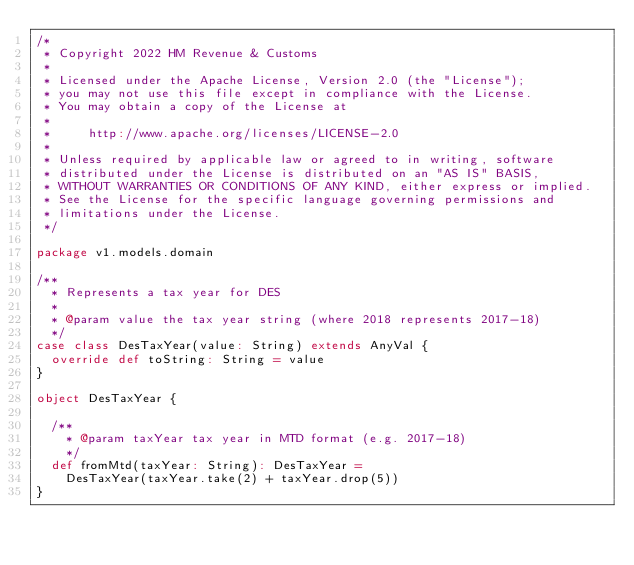<code> <loc_0><loc_0><loc_500><loc_500><_Scala_>/*
 * Copyright 2022 HM Revenue & Customs
 *
 * Licensed under the Apache License, Version 2.0 (the "License");
 * you may not use this file except in compliance with the License.
 * You may obtain a copy of the License at
 *
 *     http://www.apache.org/licenses/LICENSE-2.0
 *
 * Unless required by applicable law or agreed to in writing, software
 * distributed under the License is distributed on an "AS IS" BASIS,
 * WITHOUT WARRANTIES OR CONDITIONS OF ANY KIND, either express or implied.
 * See the License for the specific language governing permissions and
 * limitations under the License.
 */

package v1.models.domain

/**
  * Represents a tax year for DES
  *
  * @param value the tax year string (where 2018 represents 2017-18)
  */
case class DesTaxYear(value: String) extends AnyVal {
  override def toString: String = value
}

object DesTaxYear {

  /**
    * @param taxYear tax year in MTD format (e.g. 2017-18)
    */
  def fromMtd(taxYear: String): DesTaxYear =
    DesTaxYear(taxYear.take(2) + taxYear.drop(5))
}
</code> 